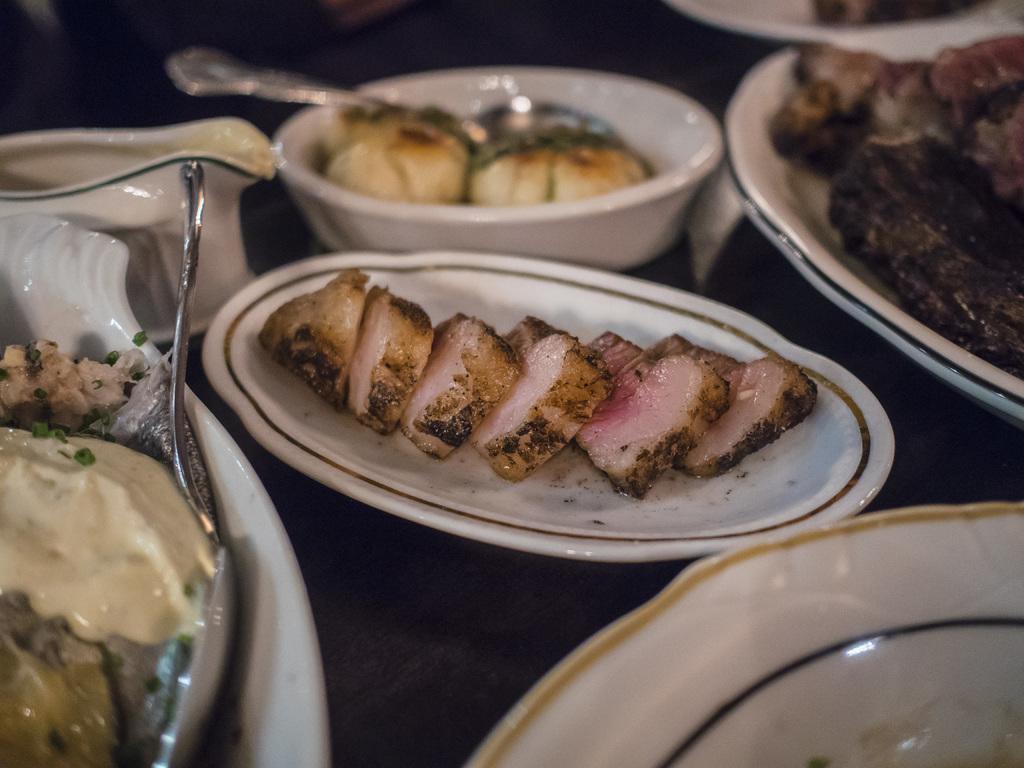Describe this image in one or two sentences. This image consists of food which is on the plates in the center. 